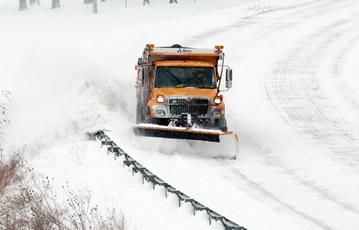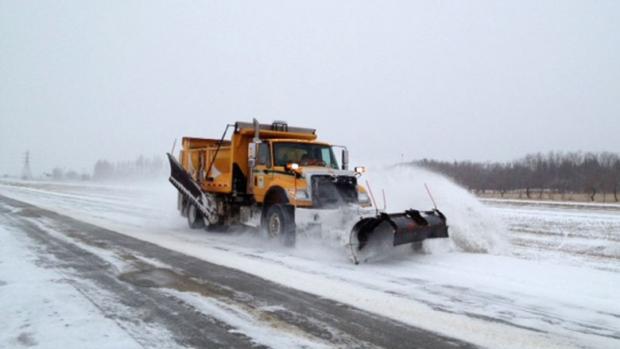The first image is the image on the left, the second image is the image on the right. For the images displayed, is the sentence "One image shows just one truck with a solid orange plow." factually correct? Answer yes or no. No. 